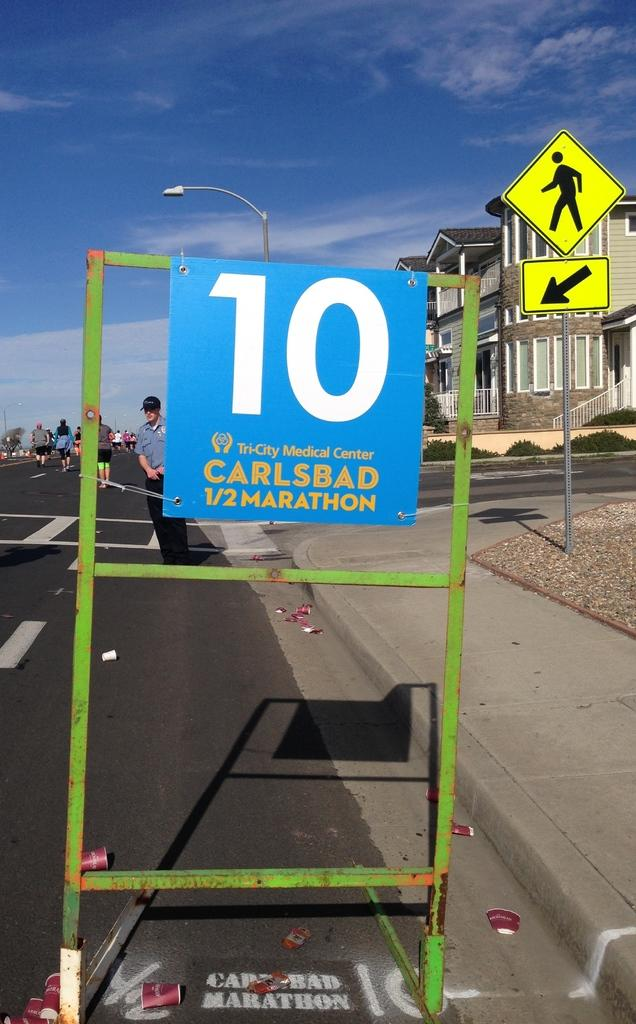<image>
Share a concise interpretation of the image provided. A sign on the road that reads 10 Carlsbad 1/2 marathon. 